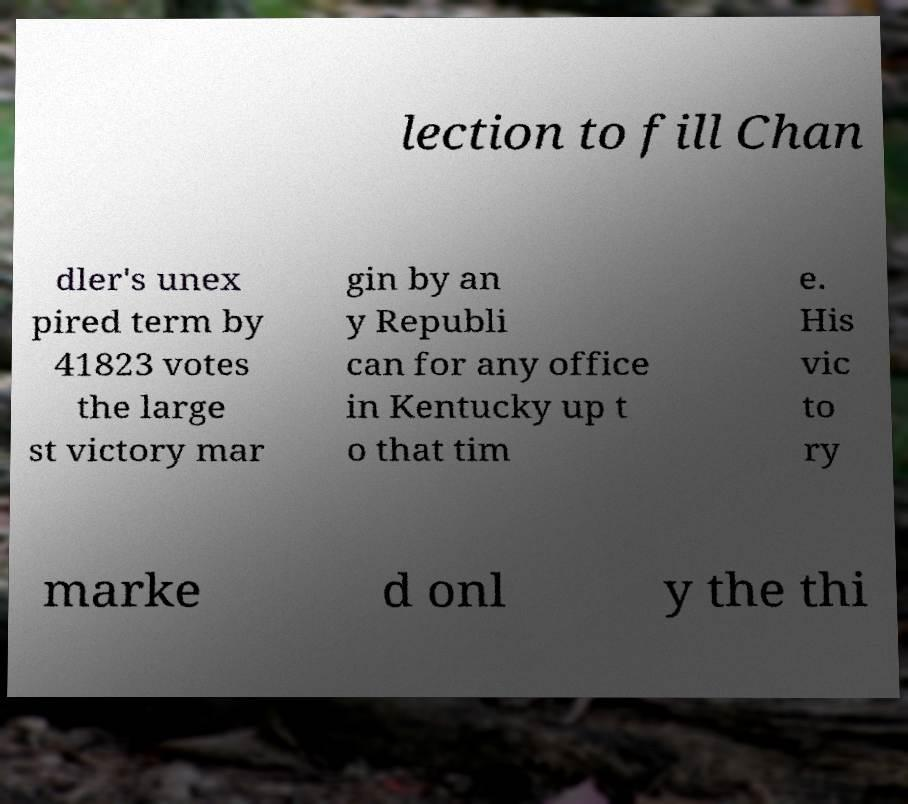For documentation purposes, I need the text within this image transcribed. Could you provide that? lection to fill Chan dler's unex pired term by 41823 votes the large st victory mar gin by an y Republi can for any office in Kentucky up t o that tim e. His vic to ry marke d onl y the thi 